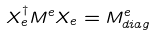Convert formula to latex. <formula><loc_0><loc_0><loc_500><loc_500>X _ { e } ^ { \dagger } M ^ { e } X _ { e } = M ^ { e } _ { d i a g }</formula> 